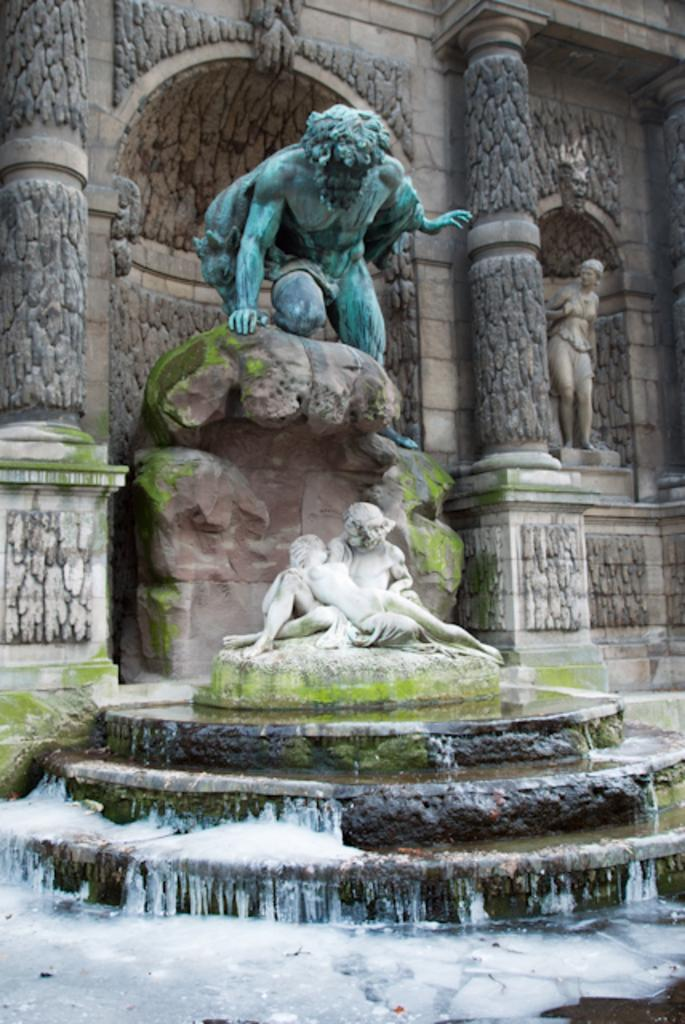What is the main subject of the statue in the image? There is a statue of a man in the image. What natural feature is present in the image? There is a waterfall in the image. Where is the statue located in relation to the waterfall? The statue is above the waterfall. What can be seen in the background of the image? There is a wall in the background of the image. What architectural features are present on the wall? The wall has pillars and designs on it. What type of shoes is the man in the statue wearing? The man in the statue is not wearing any shoes, as it is a statue and not a real person. How many wings can be seen on the statue? There are no wings present on the statue; it is a statue of a man. 